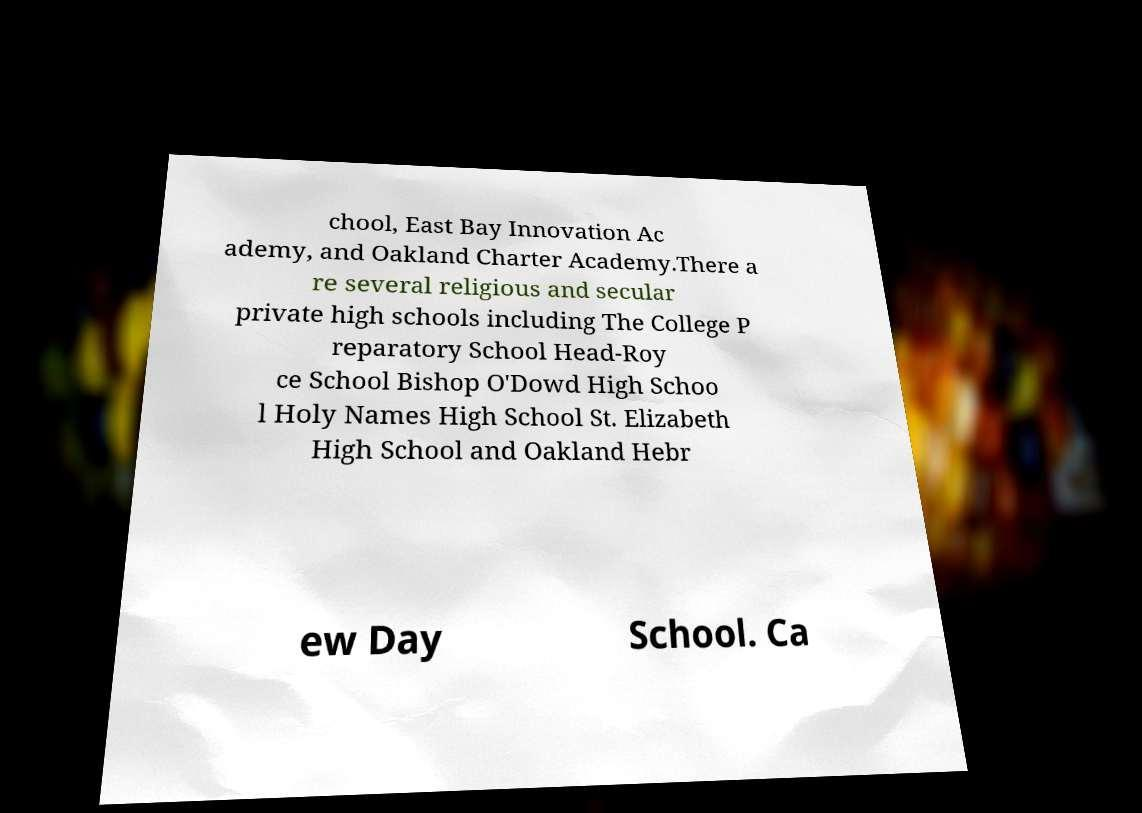There's text embedded in this image that I need extracted. Can you transcribe it verbatim? chool, East Bay Innovation Ac ademy, and Oakland Charter Academy.There a re several religious and secular private high schools including The College P reparatory School Head-Roy ce School Bishop O'Dowd High Schoo l Holy Names High School St. Elizabeth High School and Oakland Hebr ew Day School. Ca 